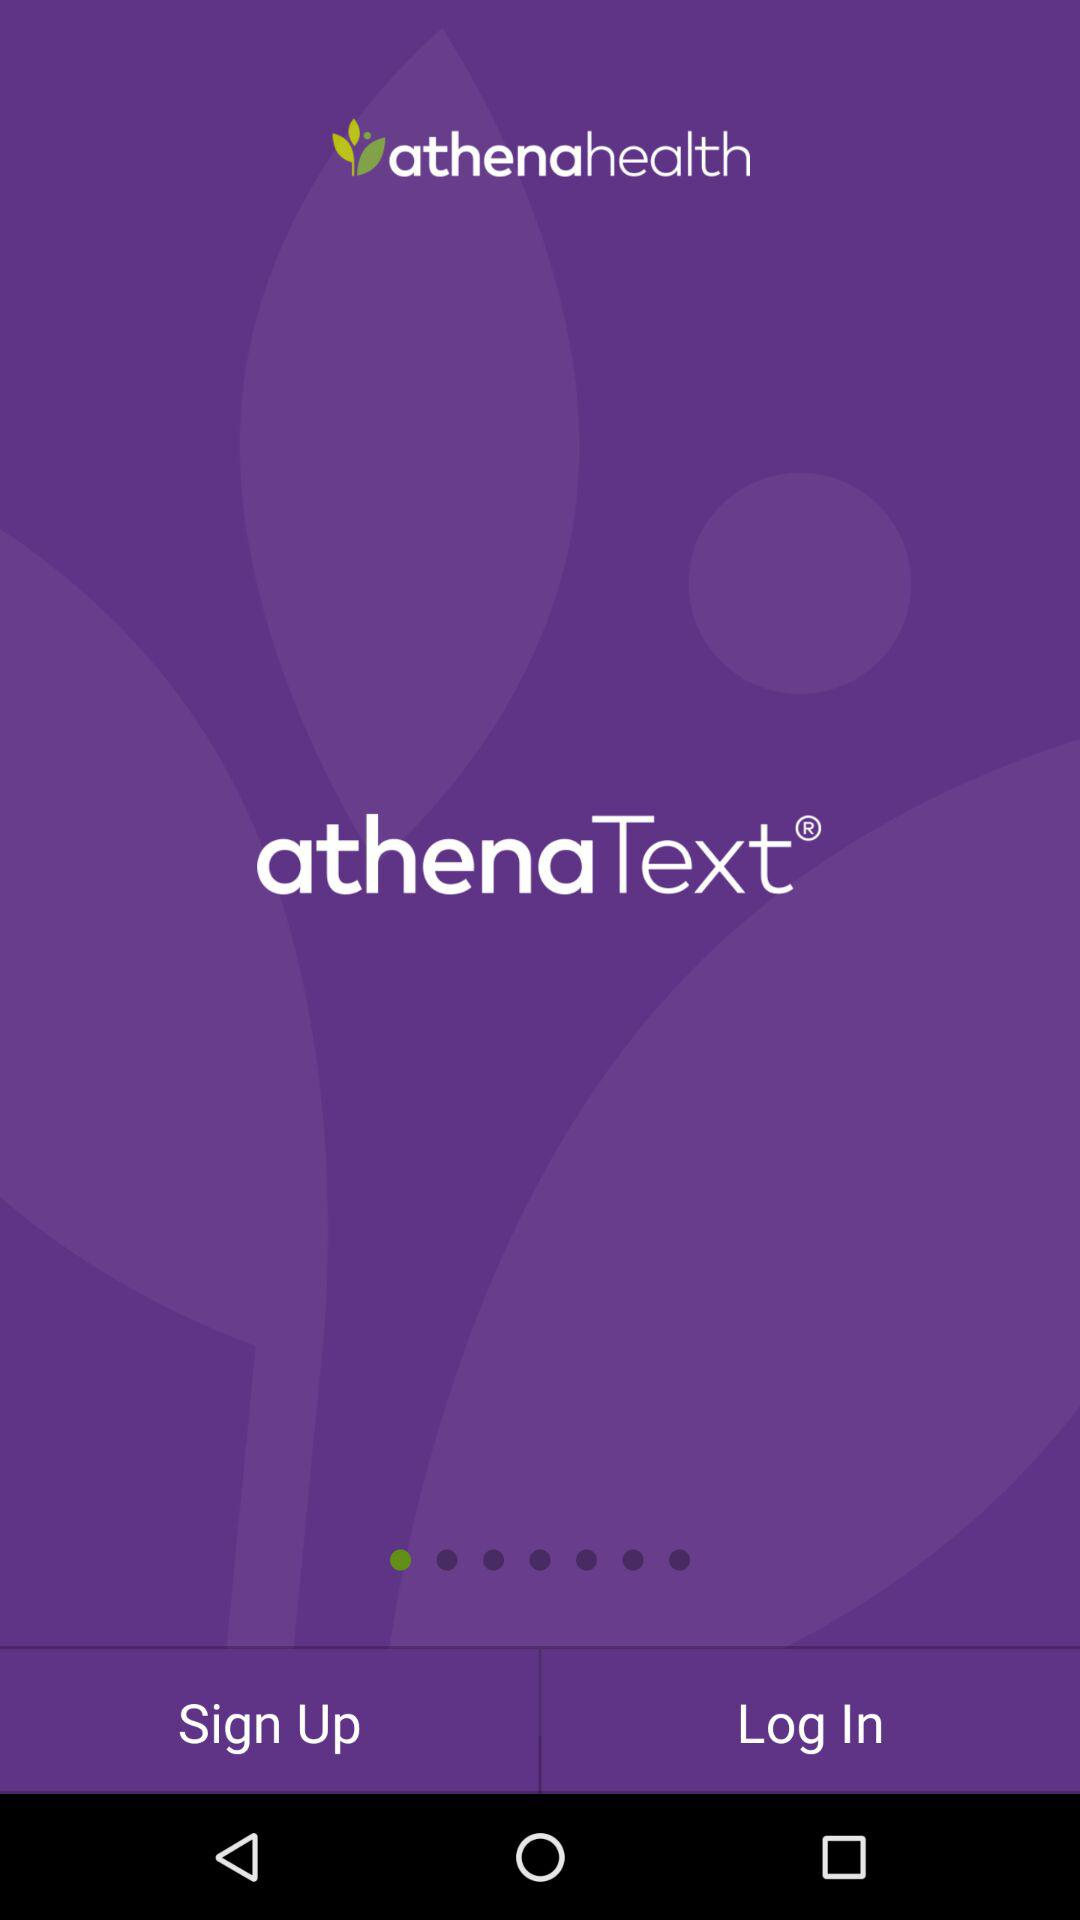What is athenahealth: The name of the application is "athenahealth". 